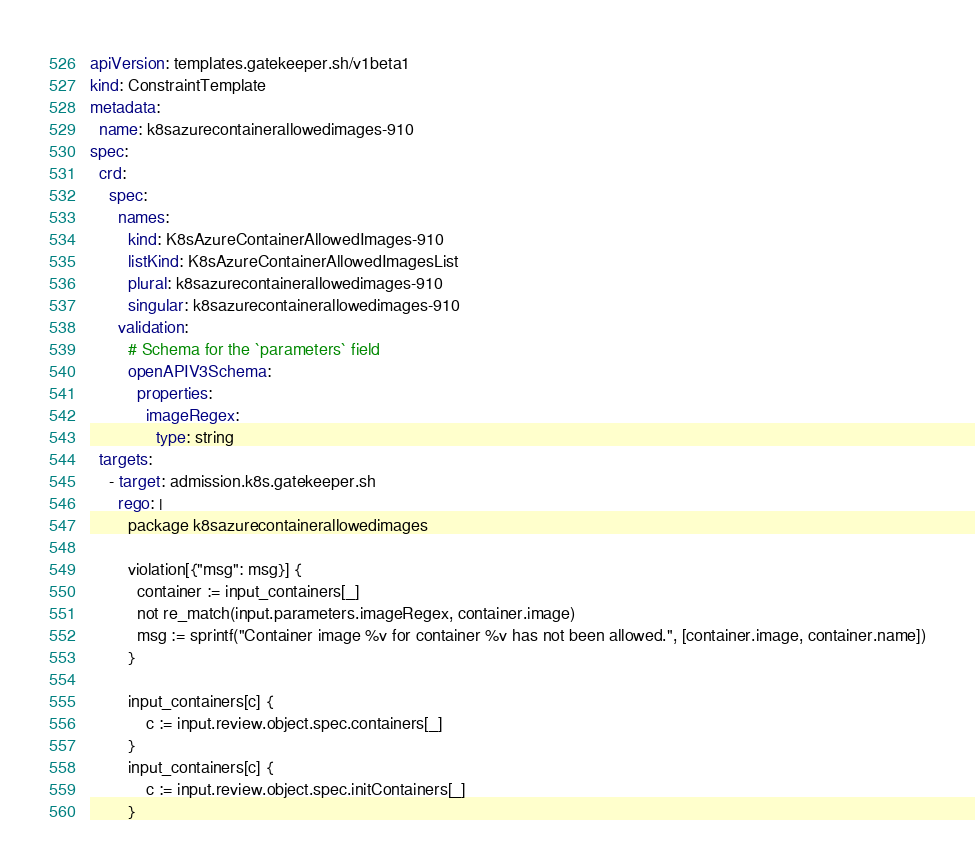Convert code to text. <code><loc_0><loc_0><loc_500><loc_500><_YAML_>apiVersion: templates.gatekeeper.sh/v1beta1
kind: ConstraintTemplate
metadata:
  name: k8sazurecontainerallowedimages-910
spec:
  crd:
    spec:
      names:
        kind: K8sAzureContainerAllowedImages-910
        listKind: K8sAzureContainerAllowedImagesList
        plural: k8sazurecontainerallowedimages-910
        singular: k8sazurecontainerallowedimages-910
      validation:
        # Schema for the `parameters` field
        openAPIV3Schema:
          properties:
            imageRegex:
              type: string
  targets:
    - target: admission.k8s.gatekeeper.sh
      rego: |
        package k8sazurecontainerallowedimages

        violation[{"msg": msg}] {
          container := input_containers[_]
          not re_match(input.parameters.imageRegex, container.image)
          msg := sprintf("Container image %v for container %v has not been allowed.", [container.image, container.name])
        }

        input_containers[c] {
            c := input.review.object.spec.containers[_]
        }
        input_containers[c] {
            c := input.review.object.spec.initContainers[_]
        }</code> 